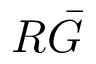Convert formula to latex. <formula><loc_0><loc_0><loc_500><loc_500>R \bar { G }</formula> 